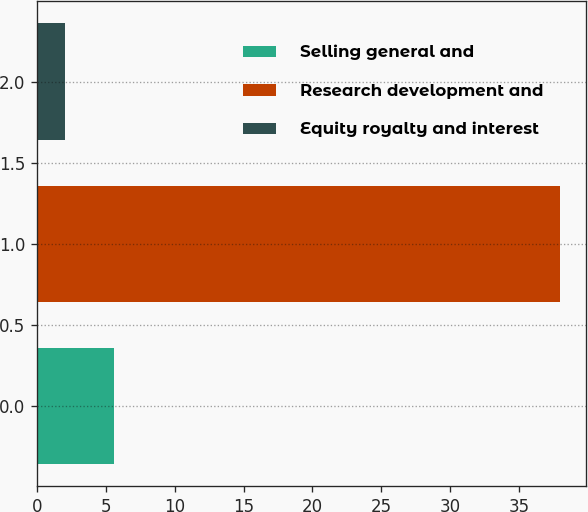Convert chart. <chart><loc_0><loc_0><loc_500><loc_500><bar_chart><fcel>Selling general and<fcel>Research development and<fcel>Equity royalty and interest<nl><fcel>5.6<fcel>38<fcel>2<nl></chart> 